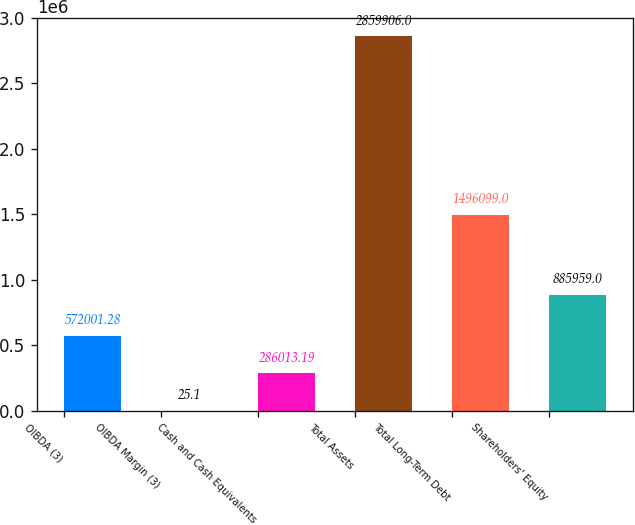<chart> <loc_0><loc_0><loc_500><loc_500><bar_chart><fcel>OIBDA (3)<fcel>OIBDA Margin (3)<fcel>Cash and Cash Equivalents<fcel>Total Assets<fcel>Total Long-Term Debt<fcel>Shareholders' Equity<nl><fcel>572001<fcel>25.1<fcel>286013<fcel>2.85991e+06<fcel>1.4961e+06<fcel>885959<nl></chart> 